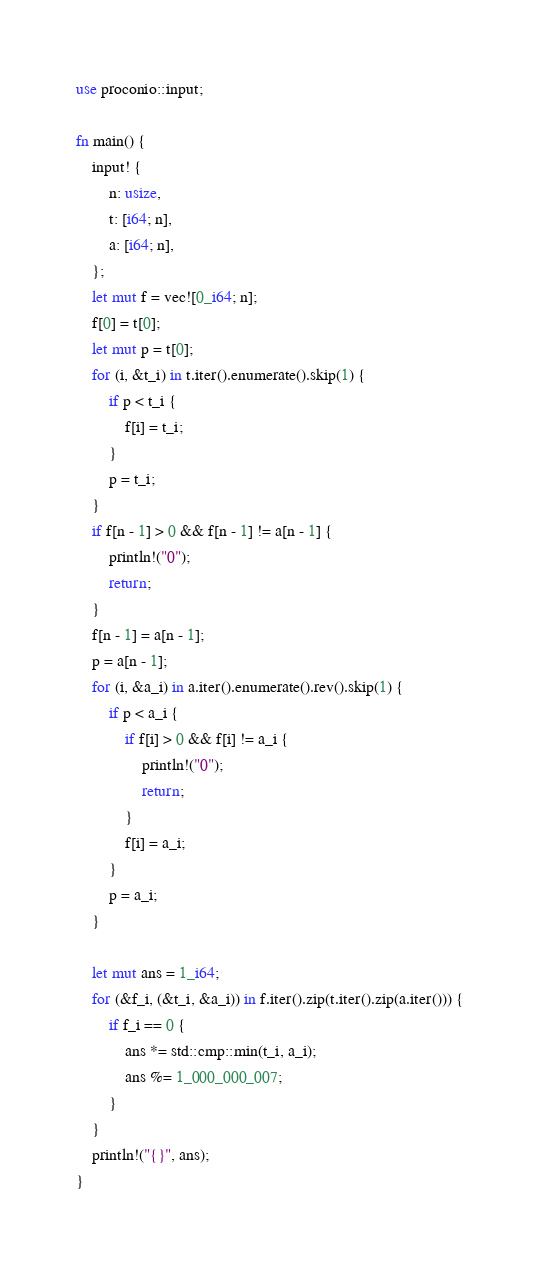Convert code to text. <code><loc_0><loc_0><loc_500><loc_500><_Rust_>use proconio::input;

fn main() {
    input! {
        n: usize,
        t: [i64; n],
        a: [i64; n],
    };
    let mut f = vec![0_i64; n];
    f[0] = t[0];
    let mut p = t[0];
    for (i, &t_i) in t.iter().enumerate().skip(1) {
        if p < t_i {
            f[i] = t_i;
        }
        p = t_i;
    }
    if f[n - 1] > 0 && f[n - 1] != a[n - 1] {
        println!("0");
        return;
    }
    f[n - 1] = a[n - 1];
    p = a[n - 1];
    for (i, &a_i) in a.iter().enumerate().rev().skip(1) {
        if p < a_i {
            if f[i] > 0 && f[i] != a_i {
                println!("0");
                return;
            }
            f[i] = a_i;
        }
        p = a_i;
    }

    let mut ans = 1_i64;
    for (&f_i, (&t_i, &a_i)) in f.iter().zip(t.iter().zip(a.iter())) {
        if f_i == 0 {
            ans *= std::cmp::min(t_i, a_i);
            ans %= 1_000_000_007;
        }
    }
    println!("{}", ans);
}
</code> 